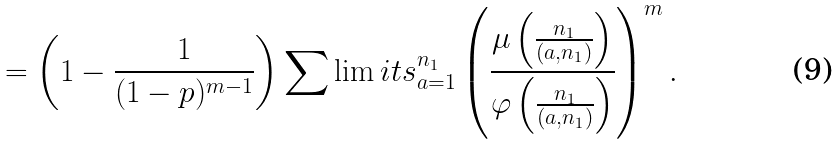Convert formula to latex. <formula><loc_0><loc_0><loc_500><loc_500>= \left ( 1 - \frac { 1 } { ( 1 - p ) ^ { m - 1 } } \right ) \sum \lim i t s _ { a = 1 } ^ { n _ { 1 } } \left ( \frac { \mu \left ( \frac { n _ { 1 } } { ( a , n _ { 1 } ) } \right ) } { \varphi \left ( \frac { n _ { 1 } } { ( a , n _ { 1 } ) } \right ) } \right ) ^ { m } .</formula> 